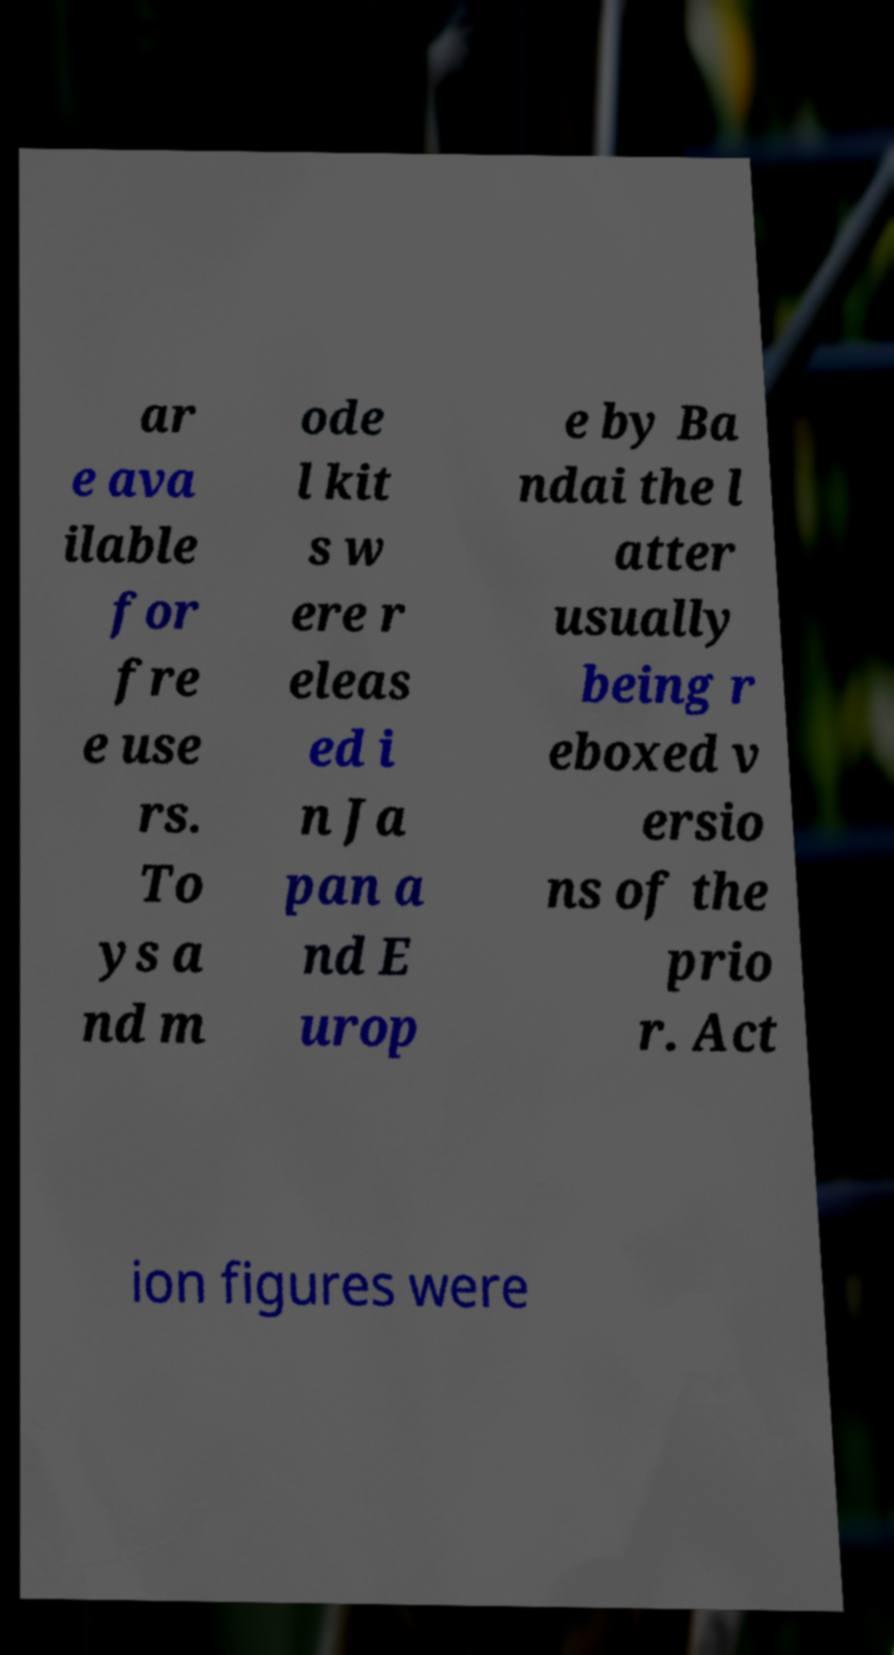What messages or text are displayed in this image? I need them in a readable, typed format. ar e ava ilable for fre e use rs. To ys a nd m ode l kit s w ere r eleas ed i n Ja pan a nd E urop e by Ba ndai the l atter usually being r eboxed v ersio ns of the prio r. Act ion figures were 